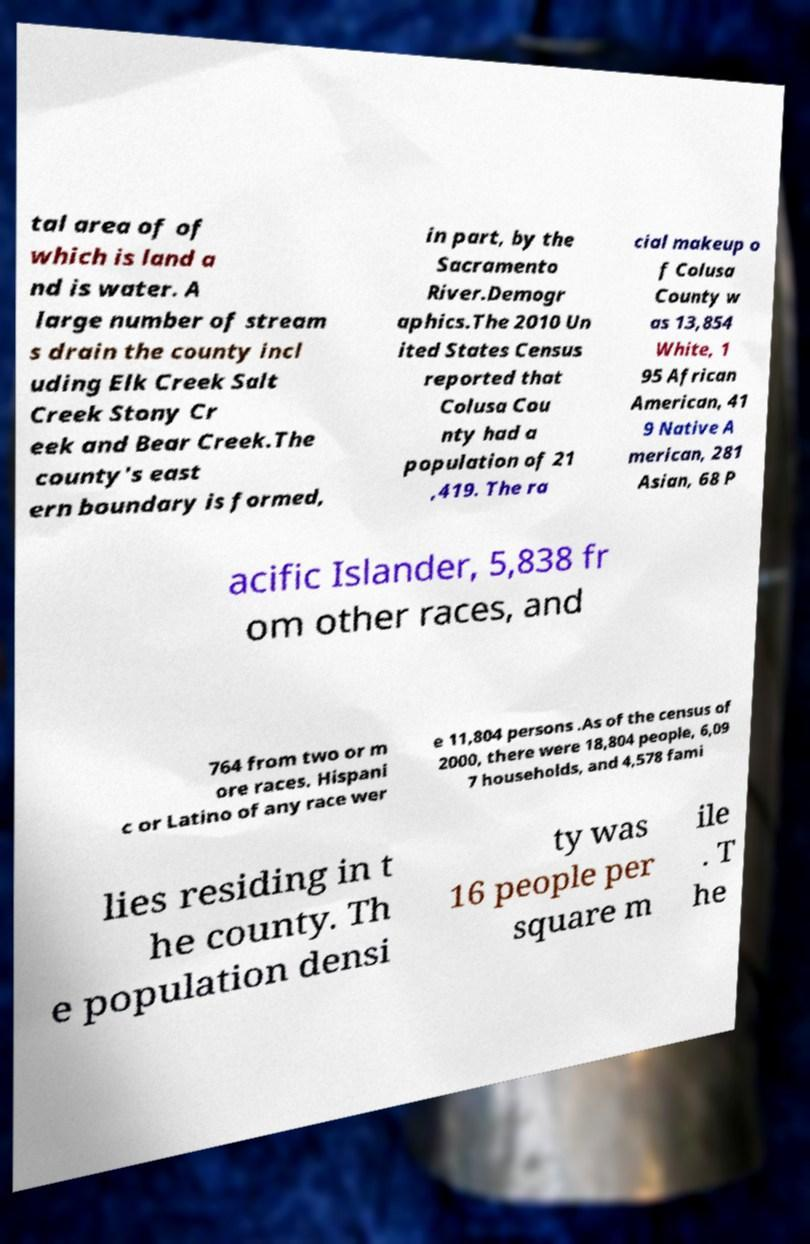There's text embedded in this image that I need extracted. Can you transcribe it verbatim? tal area of of which is land a nd is water. A large number of stream s drain the county incl uding Elk Creek Salt Creek Stony Cr eek and Bear Creek.The county's east ern boundary is formed, in part, by the Sacramento River.Demogr aphics.The 2010 Un ited States Census reported that Colusa Cou nty had a population of 21 ,419. The ra cial makeup o f Colusa County w as 13,854 White, 1 95 African American, 41 9 Native A merican, 281 Asian, 68 P acific Islander, 5,838 fr om other races, and 764 from two or m ore races. Hispani c or Latino of any race wer e 11,804 persons .As of the census of 2000, there were 18,804 people, 6,09 7 households, and 4,578 fami lies residing in t he county. Th e population densi ty was 16 people per square m ile . T he 